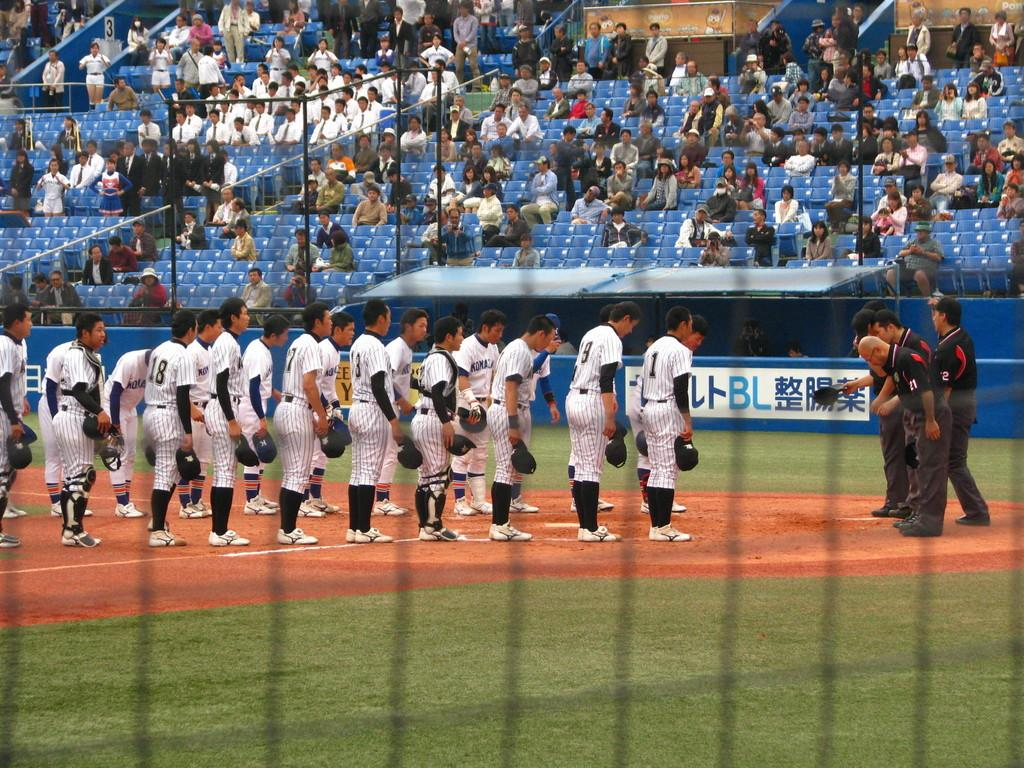<image>
Give a short and clear explanation of the subsequent image. the letters BL are on the sign next to the field 